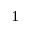<formula> <loc_0><loc_0><loc_500><loc_500>^ { 1 }</formula> 